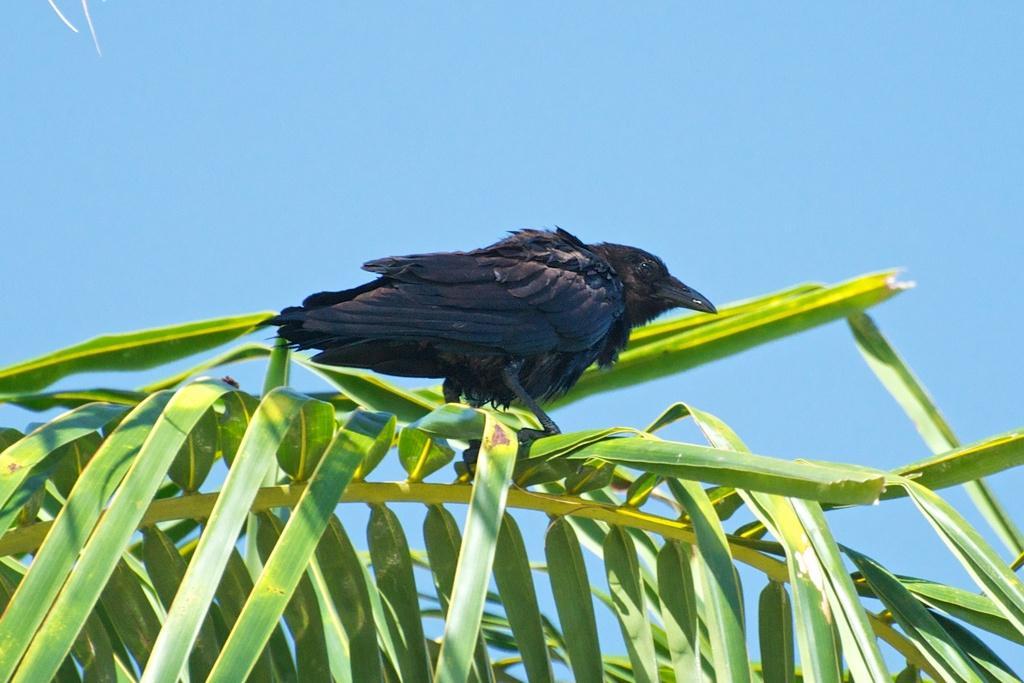Please provide a concise description of this image. In this picture I can see a bird which is of black color and it is on the leaves. In the background I can see the clear sky. 